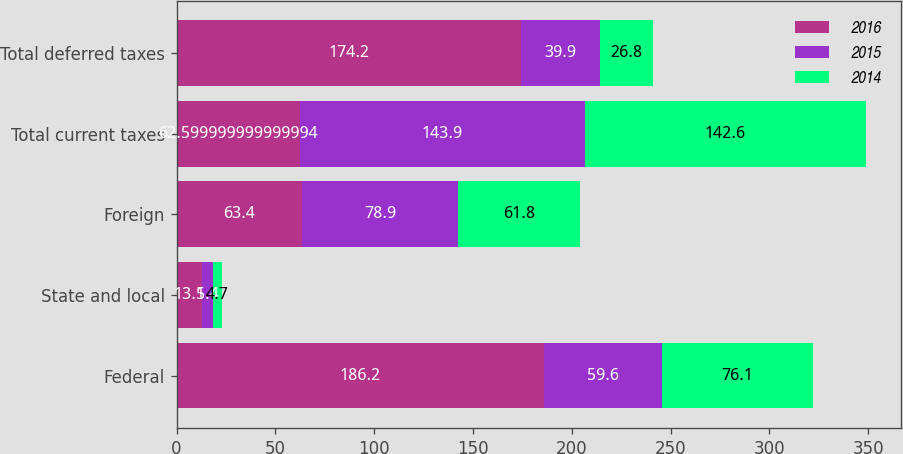Convert chart to OTSL. <chart><loc_0><loc_0><loc_500><loc_500><stacked_bar_chart><ecel><fcel>Federal<fcel>State and local<fcel>Foreign<fcel>Total current taxes<fcel>Total deferred taxes<nl><fcel>2016<fcel>186.2<fcel>13.1<fcel>63.4<fcel>62.6<fcel>174.2<nl><fcel>2015<fcel>59.6<fcel>5.4<fcel>78.9<fcel>143.9<fcel>39.9<nl><fcel>2014<fcel>76.1<fcel>4.7<fcel>61.8<fcel>142.6<fcel>26.8<nl></chart> 